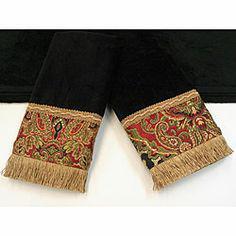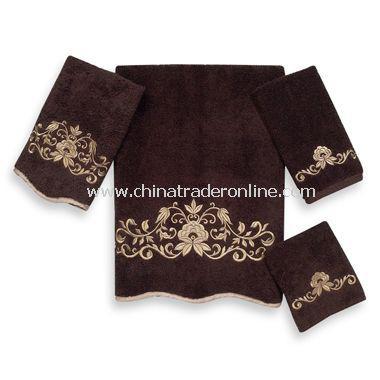The first image is the image on the left, the second image is the image on the right. For the images displayed, is the sentence "The linens in the image on the right are red" factually correct? Answer yes or no. No. The first image is the image on the left, the second image is the image on the right. Analyze the images presented: Is the assertion "One image shows a pair of yarn-fringed towels displayed on a solid towel." valid? Answer yes or no. Yes. 